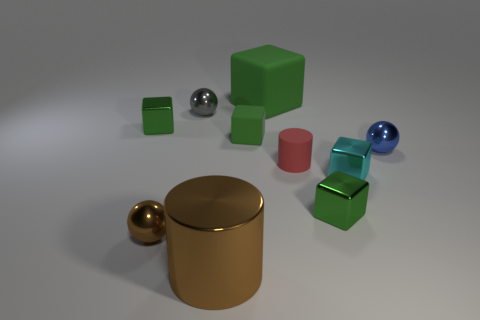There is a green thing behind the tiny shiny cube that is behind the blue ball; what is its material?
Offer a terse response. Rubber. Is the number of shiny cylinders on the right side of the small red matte cylinder less than the number of brown metallic cylinders?
Your answer should be very brief. Yes. There is a green object that is made of the same material as the large green cube; what is its shape?
Keep it short and to the point. Cube. How many other things are the same shape as the tiny blue metal thing?
Make the answer very short. 2. What number of cyan things are either tiny shiny things or big things?
Keep it short and to the point. 1. Is the shape of the small cyan shiny thing the same as the red matte thing?
Ensure brevity in your answer.  No. Is there a large brown metallic cylinder that is to the right of the tiny green shiny object that is left of the small gray metal thing?
Make the answer very short. Yes. Is the number of tiny green blocks that are behind the small red matte cylinder the same as the number of tiny shiny balls?
Your answer should be very brief. No. How many other things are there of the same size as the blue thing?
Offer a very short reply. 7. Do the tiny green thing that is to the right of the red matte cylinder and the large thing on the right side of the big metal thing have the same material?
Provide a succinct answer. No. 